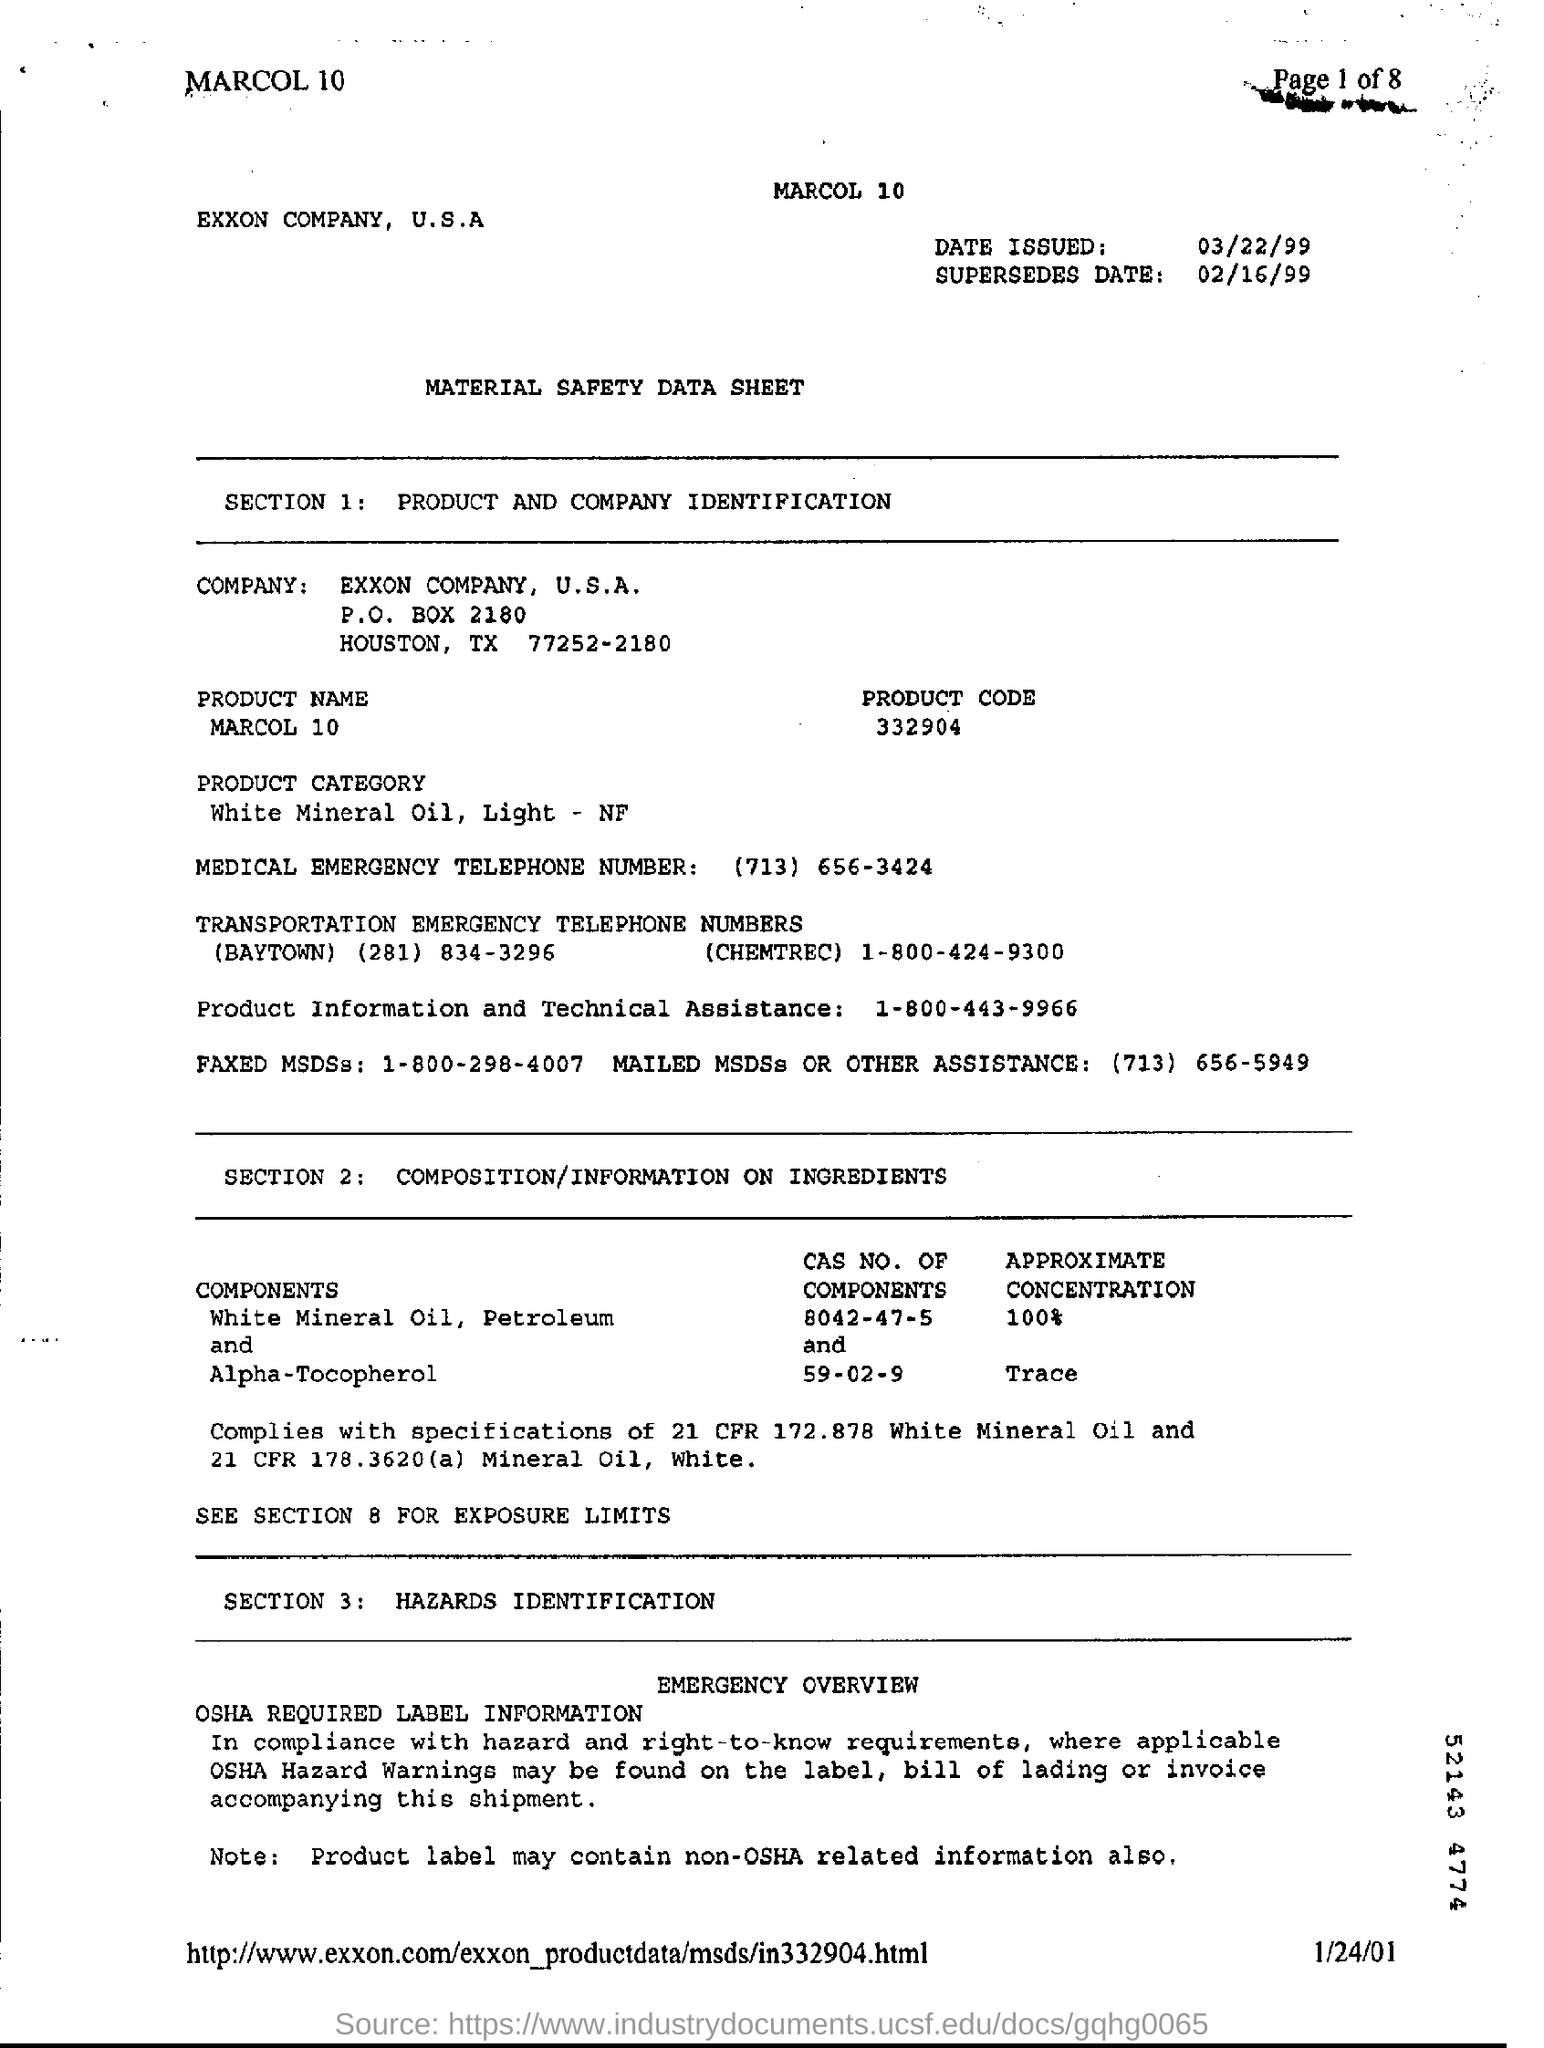What is the date issued?
Your response must be concise. 03/22/99. What is the supersedes date?
Keep it short and to the point. 02/16/99. What is written in SECTION 1?
Provide a short and direct response. PRODUCT AND COMPANY IDENTIFICATION. What is the product name?
Keep it short and to the point. MARCOL 10. What is the product code?
Give a very brief answer. 332904. What is the product category?
Give a very brief answer. White Mineral Oil, Light - NF. 